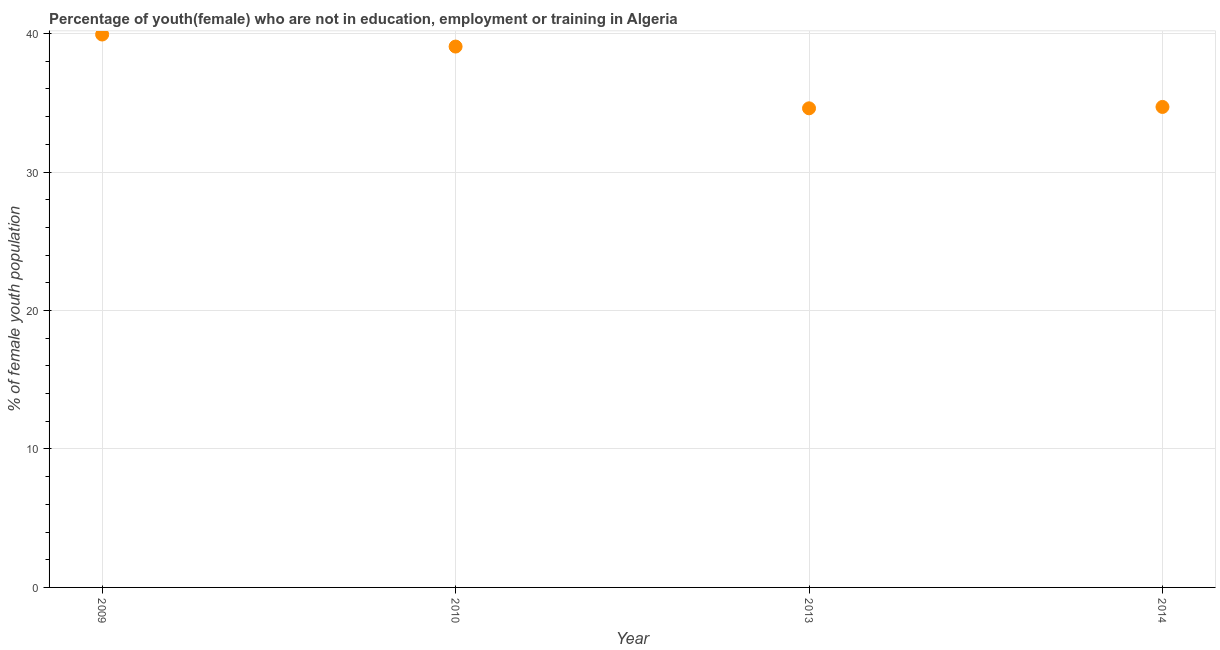What is the unemployed female youth population in 2014?
Offer a very short reply. 34.7. Across all years, what is the maximum unemployed female youth population?
Ensure brevity in your answer.  39.93. Across all years, what is the minimum unemployed female youth population?
Keep it short and to the point. 34.6. What is the sum of the unemployed female youth population?
Provide a succinct answer. 148.29. What is the difference between the unemployed female youth population in 2009 and 2010?
Your response must be concise. 0.87. What is the average unemployed female youth population per year?
Provide a short and direct response. 37.07. What is the median unemployed female youth population?
Make the answer very short. 36.88. In how many years, is the unemployed female youth population greater than 10 %?
Keep it short and to the point. 4. Do a majority of the years between 2013 and 2010 (inclusive) have unemployed female youth population greater than 34 %?
Provide a succinct answer. No. What is the ratio of the unemployed female youth population in 2013 to that in 2014?
Provide a short and direct response. 1. Is the unemployed female youth population in 2009 less than that in 2010?
Provide a succinct answer. No. What is the difference between the highest and the second highest unemployed female youth population?
Make the answer very short. 0.87. Is the sum of the unemployed female youth population in 2009 and 2013 greater than the maximum unemployed female youth population across all years?
Provide a succinct answer. Yes. What is the difference between the highest and the lowest unemployed female youth population?
Offer a very short reply. 5.33. How many dotlines are there?
Provide a short and direct response. 1. What is the title of the graph?
Make the answer very short. Percentage of youth(female) who are not in education, employment or training in Algeria. What is the label or title of the X-axis?
Your answer should be very brief. Year. What is the label or title of the Y-axis?
Your answer should be very brief. % of female youth population. What is the % of female youth population in 2009?
Offer a terse response. 39.93. What is the % of female youth population in 2010?
Keep it short and to the point. 39.06. What is the % of female youth population in 2013?
Your response must be concise. 34.6. What is the % of female youth population in 2014?
Keep it short and to the point. 34.7. What is the difference between the % of female youth population in 2009 and 2010?
Keep it short and to the point. 0.87. What is the difference between the % of female youth population in 2009 and 2013?
Your response must be concise. 5.33. What is the difference between the % of female youth population in 2009 and 2014?
Offer a terse response. 5.23. What is the difference between the % of female youth population in 2010 and 2013?
Your response must be concise. 4.46. What is the difference between the % of female youth population in 2010 and 2014?
Make the answer very short. 4.36. What is the ratio of the % of female youth population in 2009 to that in 2013?
Keep it short and to the point. 1.15. What is the ratio of the % of female youth population in 2009 to that in 2014?
Offer a very short reply. 1.15. What is the ratio of the % of female youth population in 2010 to that in 2013?
Offer a terse response. 1.13. What is the ratio of the % of female youth population in 2010 to that in 2014?
Your answer should be very brief. 1.13. 